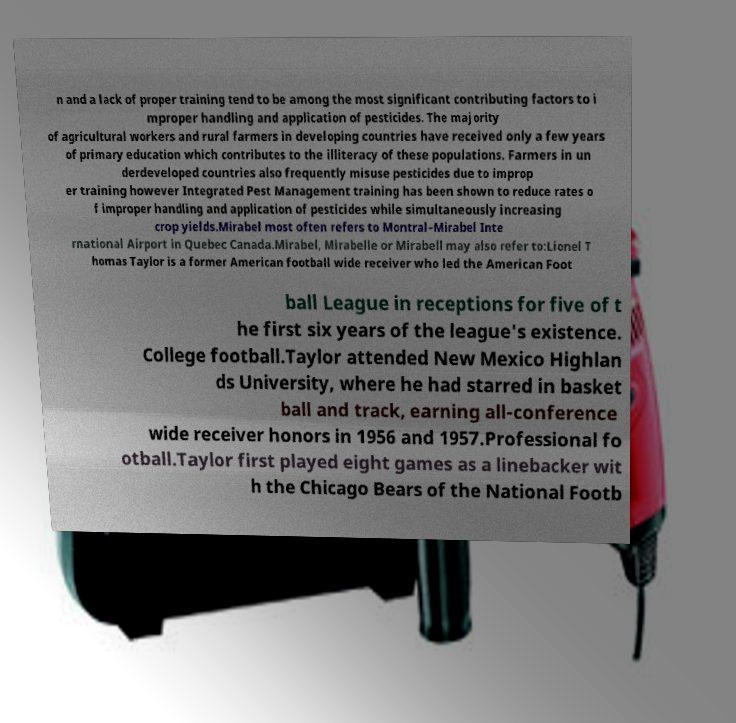Can you read and provide the text displayed in the image?This photo seems to have some interesting text. Can you extract and type it out for me? n and a lack of proper training tend to be among the most significant contributing factors to i mproper handling and application of pesticides. The majority of agricultural workers and rural farmers in developing countries have received only a few years of primary education which contributes to the illiteracy of these populations. Farmers in un derdeveloped countries also frequently misuse pesticides due to improp er training however Integrated Pest Management training has been shown to reduce rates o f improper handling and application of pesticides while simultaneously increasing crop yields.Mirabel most often refers to Montral–Mirabel Inte rnational Airport in Quebec Canada.Mirabel, Mirabelle or Mirabell may also refer to:Lionel T homas Taylor is a former American football wide receiver who led the American Foot ball League in receptions for five of t he first six years of the league's existence. College football.Taylor attended New Mexico Highlan ds University, where he had starred in basket ball and track, earning all-conference wide receiver honors in 1956 and 1957.Professional fo otball.Taylor first played eight games as a linebacker wit h the Chicago Bears of the National Footb 